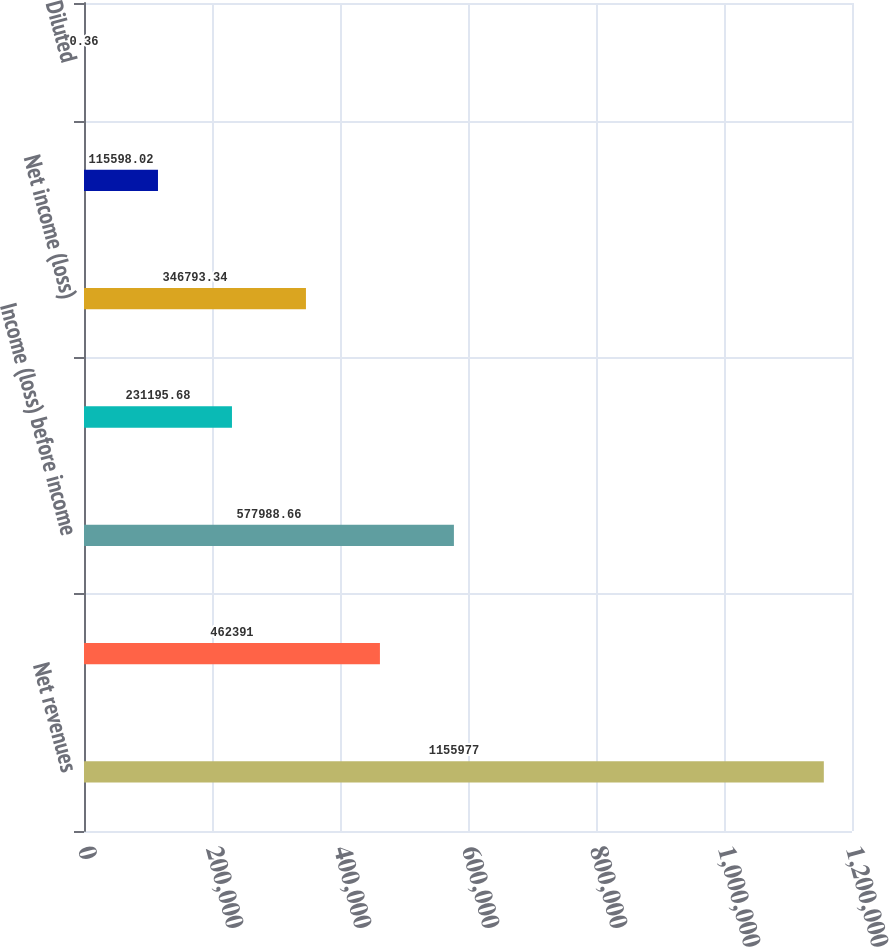Convert chart to OTSL. <chart><loc_0><loc_0><loc_500><loc_500><bar_chart><fcel>Net revenues<fcel>Operating income (loss)<fcel>Income (loss) before income<fcel>Provision (benefit) for income<fcel>Net income (loss)<fcel>Basic<fcel>Diluted<nl><fcel>1.15598e+06<fcel>462391<fcel>577989<fcel>231196<fcel>346793<fcel>115598<fcel>0.36<nl></chart> 